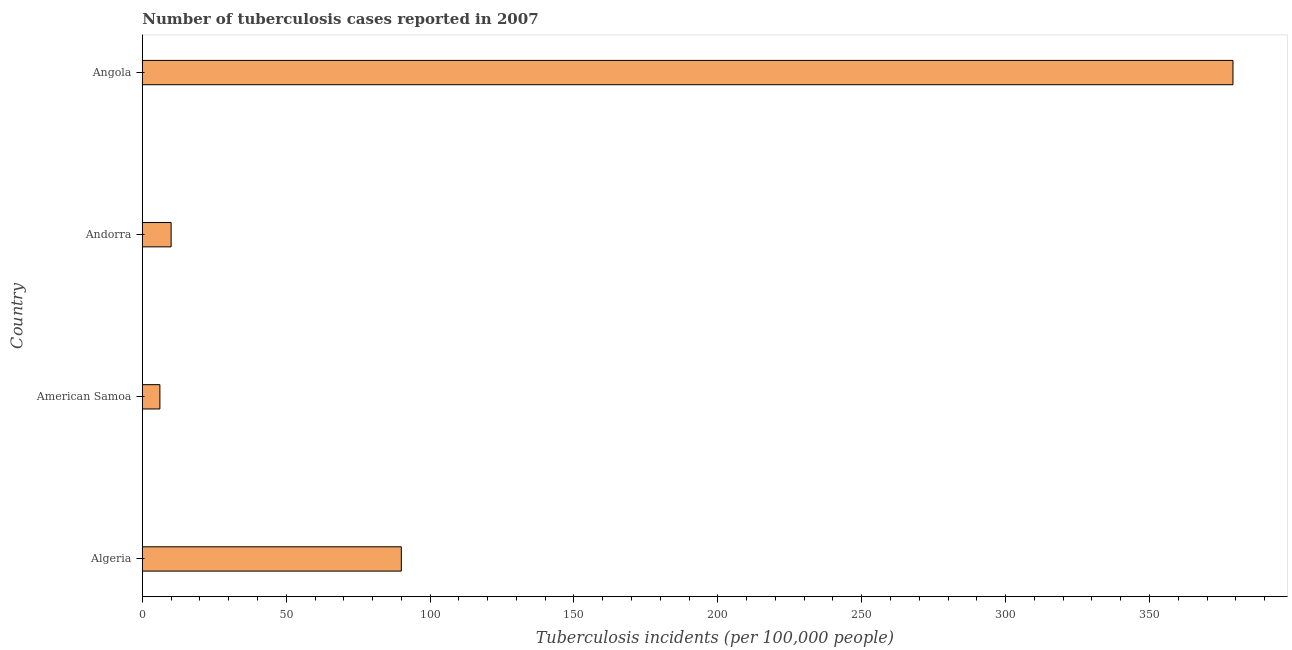Does the graph contain any zero values?
Your response must be concise. No. Does the graph contain grids?
Offer a terse response. No. What is the title of the graph?
Provide a succinct answer. Number of tuberculosis cases reported in 2007. What is the label or title of the X-axis?
Provide a succinct answer. Tuberculosis incidents (per 100,0 people). Across all countries, what is the maximum number of tuberculosis incidents?
Ensure brevity in your answer.  379. Across all countries, what is the minimum number of tuberculosis incidents?
Give a very brief answer. 6.1. In which country was the number of tuberculosis incidents maximum?
Your response must be concise. Angola. In which country was the number of tuberculosis incidents minimum?
Your response must be concise. American Samoa. What is the sum of the number of tuberculosis incidents?
Your answer should be compact. 485.1. What is the difference between the number of tuberculosis incidents in Andorra and Angola?
Ensure brevity in your answer.  -369. What is the average number of tuberculosis incidents per country?
Offer a very short reply. 121.28. What is the median number of tuberculosis incidents?
Your answer should be very brief. 50. What is the ratio of the number of tuberculosis incidents in American Samoa to that in Andorra?
Your response must be concise. 0.61. Is the number of tuberculosis incidents in American Samoa less than that in Andorra?
Your response must be concise. Yes. What is the difference between the highest and the second highest number of tuberculosis incidents?
Ensure brevity in your answer.  289. Is the sum of the number of tuberculosis incidents in Andorra and Angola greater than the maximum number of tuberculosis incidents across all countries?
Your answer should be very brief. Yes. What is the difference between the highest and the lowest number of tuberculosis incidents?
Your answer should be very brief. 372.9. In how many countries, is the number of tuberculosis incidents greater than the average number of tuberculosis incidents taken over all countries?
Your answer should be very brief. 1. How many bars are there?
Offer a terse response. 4. Are all the bars in the graph horizontal?
Make the answer very short. Yes. How many countries are there in the graph?
Make the answer very short. 4. What is the Tuberculosis incidents (per 100,000 people) in Algeria?
Offer a very short reply. 90. What is the Tuberculosis incidents (per 100,000 people) of Andorra?
Provide a succinct answer. 10. What is the Tuberculosis incidents (per 100,000 people) of Angola?
Your response must be concise. 379. What is the difference between the Tuberculosis incidents (per 100,000 people) in Algeria and American Samoa?
Keep it short and to the point. 83.9. What is the difference between the Tuberculosis incidents (per 100,000 people) in Algeria and Andorra?
Provide a succinct answer. 80. What is the difference between the Tuberculosis incidents (per 100,000 people) in Algeria and Angola?
Offer a very short reply. -289. What is the difference between the Tuberculosis incidents (per 100,000 people) in American Samoa and Andorra?
Give a very brief answer. -3.9. What is the difference between the Tuberculosis incidents (per 100,000 people) in American Samoa and Angola?
Keep it short and to the point. -372.9. What is the difference between the Tuberculosis incidents (per 100,000 people) in Andorra and Angola?
Make the answer very short. -369. What is the ratio of the Tuberculosis incidents (per 100,000 people) in Algeria to that in American Samoa?
Offer a terse response. 14.75. What is the ratio of the Tuberculosis incidents (per 100,000 people) in Algeria to that in Andorra?
Your response must be concise. 9. What is the ratio of the Tuberculosis incidents (per 100,000 people) in Algeria to that in Angola?
Make the answer very short. 0.24. What is the ratio of the Tuberculosis incidents (per 100,000 people) in American Samoa to that in Andorra?
Provide a succinct answer. 0.61. What is the ratio of the Tuberculosis incidents (per 100,000 people) in American Samoa to that in Angola?
Keep it short and to the point. 0.02. What is the ratio of the Tuberculosis incidents (per 100,000 people) in Andorra to that in Angola?
Keep it short and to the point. 0.03. 